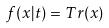Convert formula to latex. <formula><loc_0><loc_0><loc_500><loc_500>f ( x | t ) = T r ( x )</formula> 